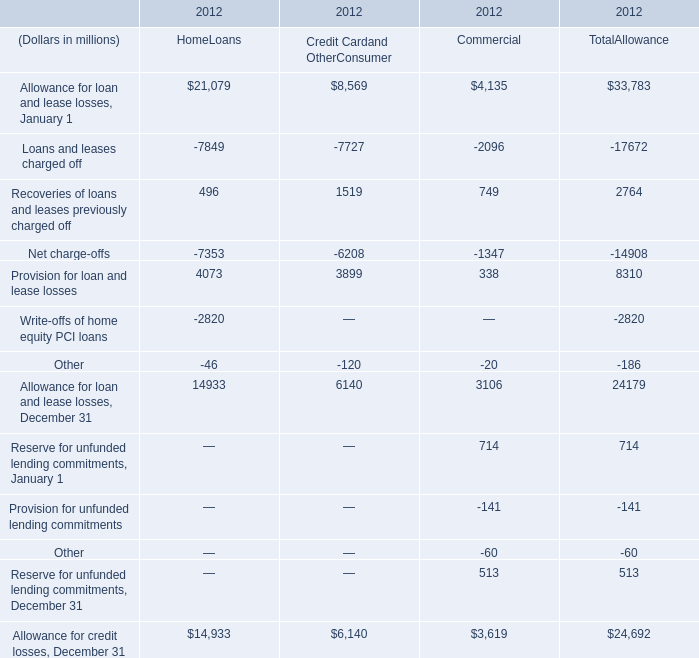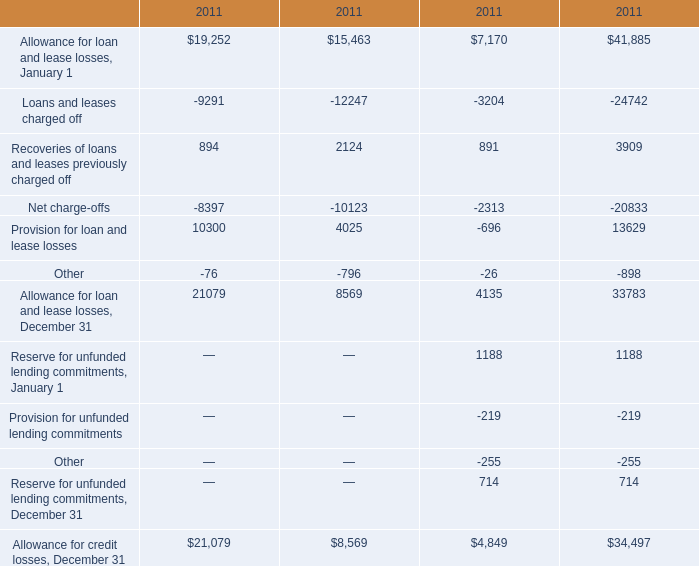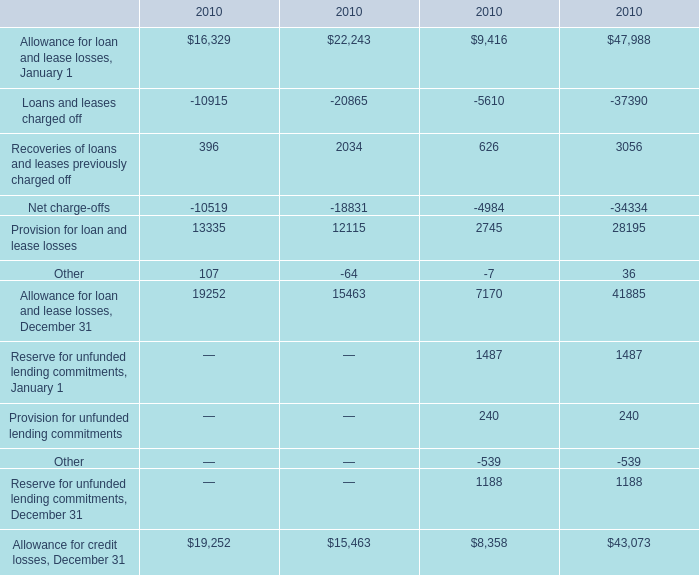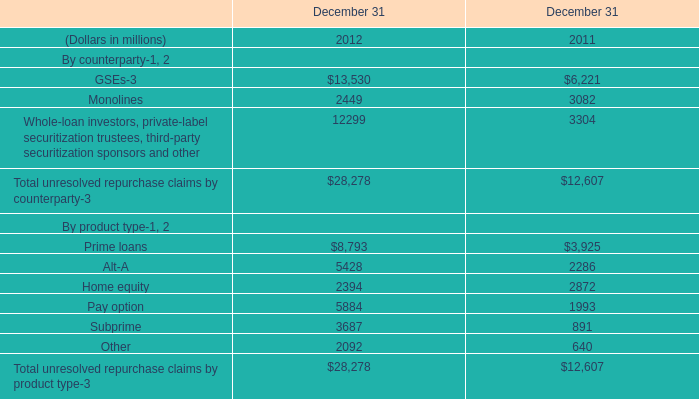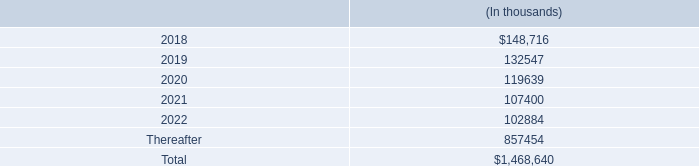What's the total amount of Provision for loan and lease losses excluding those negative ones in 2011? 
Computations: ((10300 + 4025) + 13629)
Answer: 27954.0. 